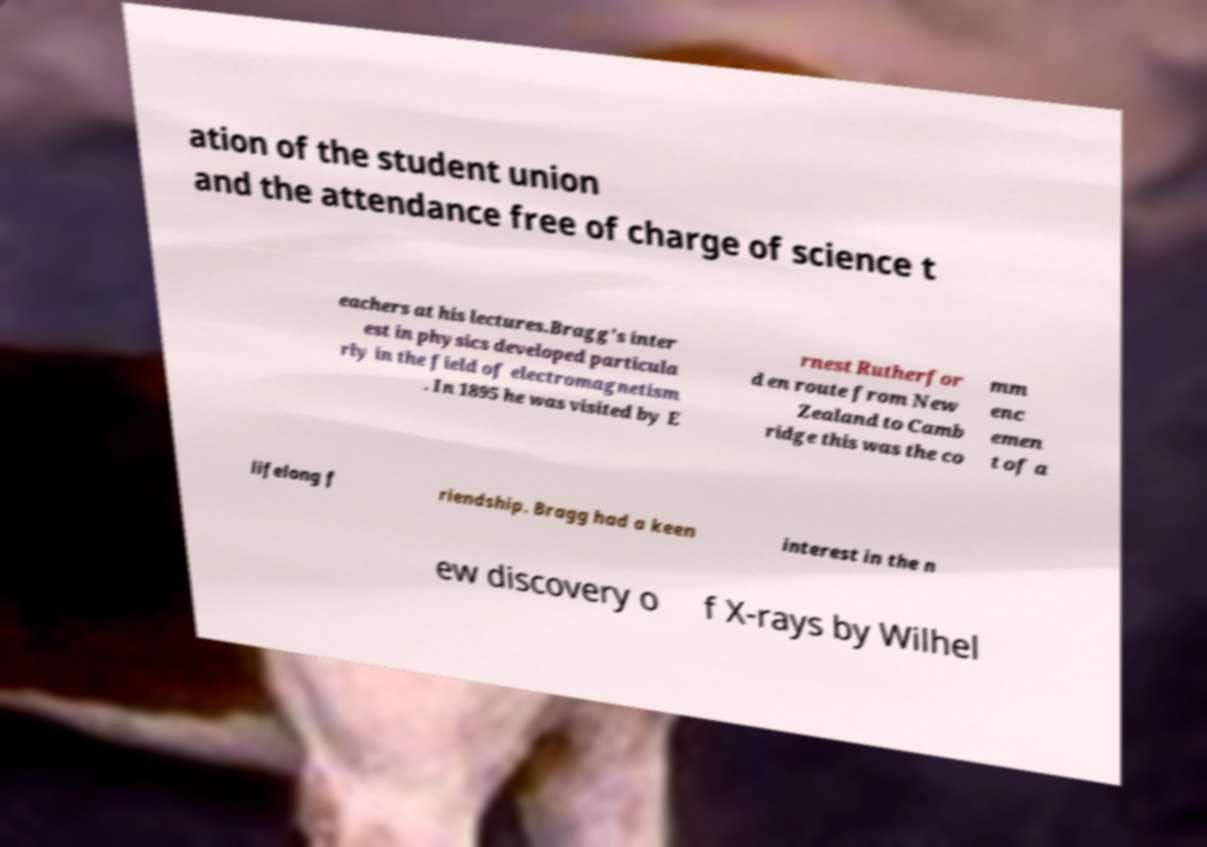What messages or text are displayed in this image? I need them in a readable, typed format. ation of the student union and the attendance free of charge of science t eachers at his lectures.Bragg's inter est in physics developed particula rly in the field of electromagnetism . In 1895 he was visited by E rnest Rutherfor d en route from New Zealand to Camb ridge this was the co mm enc emen t of a lifelong f riendship. Bragg had a keen interest in the n ew discovery o f X-rays by Wilhel 